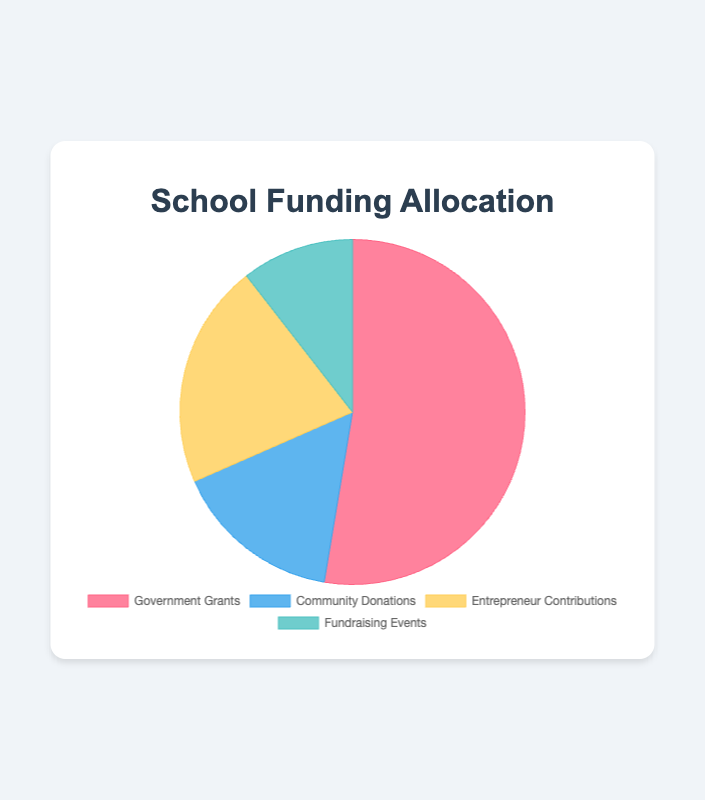What percentage of the total funding comes from Government Grants? The Government Grants amount to $50,000. The total funding is determined by summing up all amounts: $50,000 (Government Grants) + $15,000 (Community Donations) + $20,000 (Entrepreneur Contributions) + $10,000 (Fundraising Events) = $95,000. The percentage is calculated as ($50,000 / $95,000) * 100 ≈ 52.63%
Answer: 52.63% Which funding source contributes the least amount? Comparing all the amounts, Government Grants = $50,000, Community Donations = $15,000, Entrepreneur Contributions = $20,000, Fundraising Events = $10,000. Therefore, Fundraising Events contribute the least amount.
Answer: Fundraising Events What is the total funding from sources other than Government Grants? Funding from sources other than Government Grants is the sum of Community Donations, Entrepreneur Contributions, and Fundraising Events: $15,000 + $20,000 + $10,000 = $45,000.
Answer: $45,000 How much more funding comes from Government Grants compared to Entrepreneur Contributions? Government Grants provide $50,000, and Entrepreneur Contributions provide $20,000. The difference is $50,000 - $20,000 = $30,000.
Answer: $30,000 What is the average funding amount across all sources? The total funding is $95,000, and there are 4 sources. The average funding amount is calculated as $95,000 / 4 = $23,750.
Answer: $23,750 Which two sources have the closest funding amounts, and what is the difference? The funding amounts are Government Grants = $50,000, Community Donations = $15,000, Entrepreneur Contributions = $20,000, Fundraising Events = $10,000. The closest amounts are Community Donations and Entrepreneur Contributions with a difference of $20,000 - $15,000 = $5,000.
Answer: Community Donations and Entrepreneur Contributions, $5,000 If Fundraising Events raised $5,000 more, what would be its new percentage contribution? New amount from Fundraising Events is $10,000 + $5,000 = $15,000. The new total funding is $95,000 + $5,000 = $100,000. The new percentage contribution is ($15,000 / $100,000) * 100 = 15%.
Answer: 15% How much more is the funding from Government Grants compared to the combined amount from Community Donations and Fundraising Events? The combined amount from Community Donations and Fundraising Events is $15,000 + $10,000 = $25,000. The difference compared to Government Grants is $50,000 - $25,000 = $25,000.
Answer: $25,000 Which funding source has the second largest contribution? The amounts are Government Grants = $50,000, Community Donations = $15,000, Entrepreneur Contributions = $20,000, Fundraising Events = $10,000. The second largest contribution is from Entrepreneur Contributions with $20,000.
Answer: Entrepreneur Contributions 